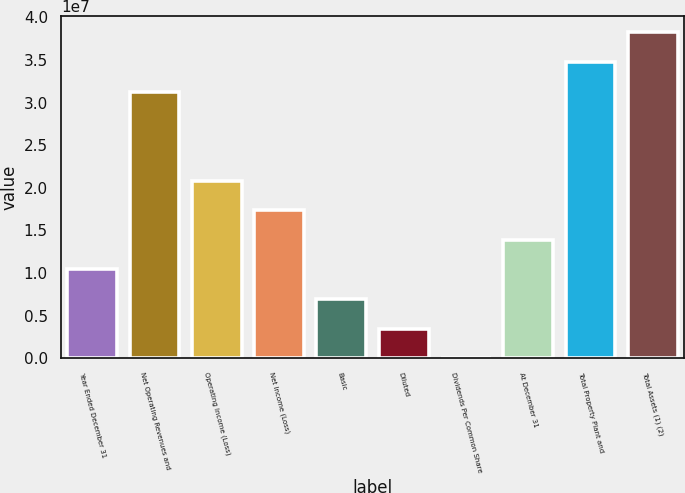Convert chart. <chart><loc_0><loc_0><loc_500><loc_500><bar_chart><fcel>Year Ended December 31<fcel>Net Operating Revenues and<fcel>Operating Income (Loss)<fcel>Net Income (Loss)<fcel>Basic<fcel>Diluted<fcel>Dividends Per Common Share<fcel>At December 31<fcel>Total Property Plant and<fcel>Total Assets (1) (2)<nl><fcel>1.04276e+07<fcel>3.12827e+07<fcel>2.08552e+07<fcel>1.73793e+07<fcel>6.95172e+06<fcel>3.47586e+06<fcel>0.58<fcel>1.39034e+07<fcel>3.47586e+07<fcel>3.82345e+07<nl></chart> 